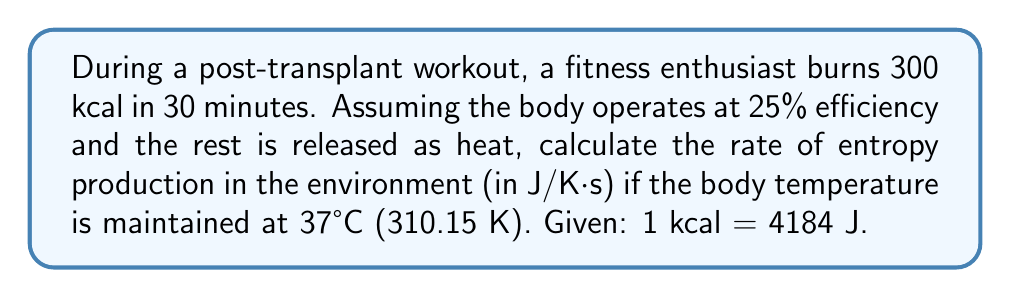Could you help me with this problem? Let's approach this step-by-step:

1) First, convert the energy burned from kcal to Joules:
   $$300 \text{ kcal} \times 4184 \text{ J/kcal} = 1,255,200 \text{ J}$$

2) The body operates at 25% efficiency, meaning 75% of this energy is released as heat:
   $$Q = 0.75 \times 1,255,200 \text{ J} = 941,400 \text{ J}$$

3) This heat is released over 30 minutes = 1800 seconds. The rate of heat release is:
   $$\dot{Q} = \frac{941,400 \text{ J}}{1800 \text{ s}} = 523 \text{ J/s}$$

4) The entropy production rate in the environment is given by:
   $$\dot{S} = \frac{\dot{Q}}{T}$$
   where $T$ is the body temperature in Kelvin.

5) Substituting the values:
   $$\dot{S} = \frac{523 \text{ J/s}}{310.15 \text{ K}} = 1.686 \text{ J/K⋅s}$$

Thus, the rate of entropy production in the environment is approximately 1.686 J/K⋅s.
Answer: 1.686 J/K⋅s 